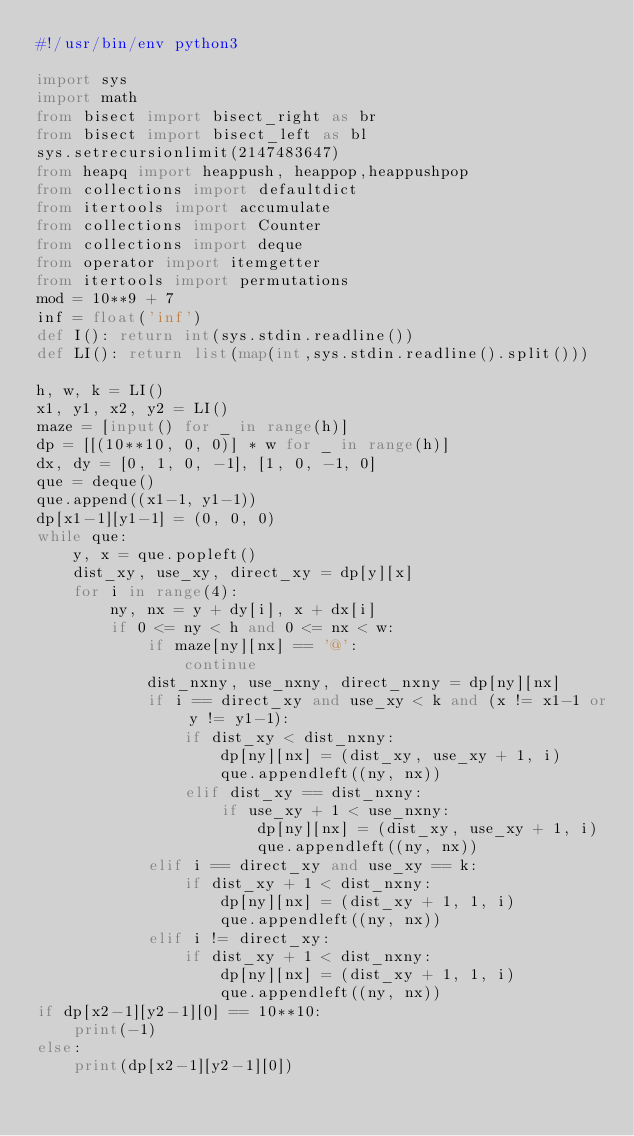<code> <loc_0><loc_0><loc_500><loc_500><_Python_>#!/usr/bin/env python3

import sys
import math
from bisect import bisect_right as br
from bisect import bisect_left as bl
sys.setrecursionlimit(2147483647)
from heapq import heappush, heappop,heappushpop
from collections import defaultdict
from itertools import accumulate
from collections import Counter
from collections import deque
from operator import itemgetter
from itertools import permutations
mod = 10**9 + 7
inf = float('inf')
def I(): return int(sys.stdin.readline())
def LI(): return list(map(int,sys.stdin.readline().split()))

h, w, k = LI()
x1, y1, x2, y2 = LI()
maze = [input() for _ in range(h)]
dp = [[(10**10, 0, 0)] * w for _ in range(h)]
dx, dy = [0, 1, 0, -1], [1, 0, -1, 0]
que = deque()
que.append((x1-1, y1-1))
dp[x1-1][y1-1] = (0, 0, 0)
while que:
    y, x = que.popleft()
    dist_xy, use_xy, direct_xy = dp[y][x]
    for i in range(4):
        ny, nx = y + dy[i], x + dx[i]
        if 0 <= ny < h and 0 <= nx < w:
            if maze[ny][nx] == '@':
                continue
            dist_nxny, use_nxny, direct_nxny = dp[ny][nx]
            if i == direct_xy and use_xy < k and (x != x1-1 or y != y1-1):
                if dist_xy < dist_nxny:
                    dp[ny][nx] = (dist_xy, use_xy + 1, i)
                    que.appendleft((ny, nx))
                elif dist_xy == dist_nxny:
                    if use_xy + 1 < use_nxny:
                        dp[ny][nx] = (dist_xy, use_xy + 1, i)
                        que.appendleft((ny, nx))
            elif i == direct_xy and use_xy == k:
                if dist_xy + 1 < dist_nxny:
                    dp[ny][nx] = (dist_xy + 1, 1, i)
                    que.appendleft((ny, nx))
            elif i != direct_xy:
                if dist_xy + 1 < dist_nxny:
                    dp[ny][nx] = (dist_xy + 1, 1, i)
                    que.appendleft((ny, nx))
if dp[x2-1][y2-1][0] == 10**10:
    print(-1)
else:
    print(dp[x2-1][y2-1][0])

            
    
</code> 